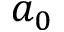Convert formula to latex. <formula><loc_0><loc_0><loc_500><loc_500>a _ { 0 }</formula> 